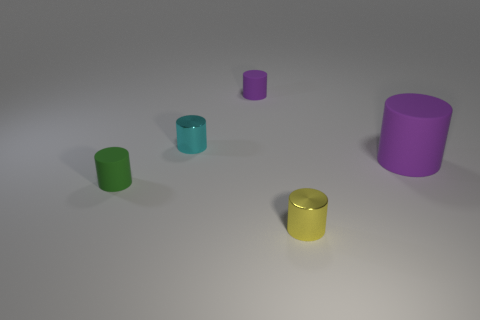How many big things are yellow balls or yellow metallic cylinders? In the image presented, there is one large yellow metallic cylinder. No yellow balls are visible. 